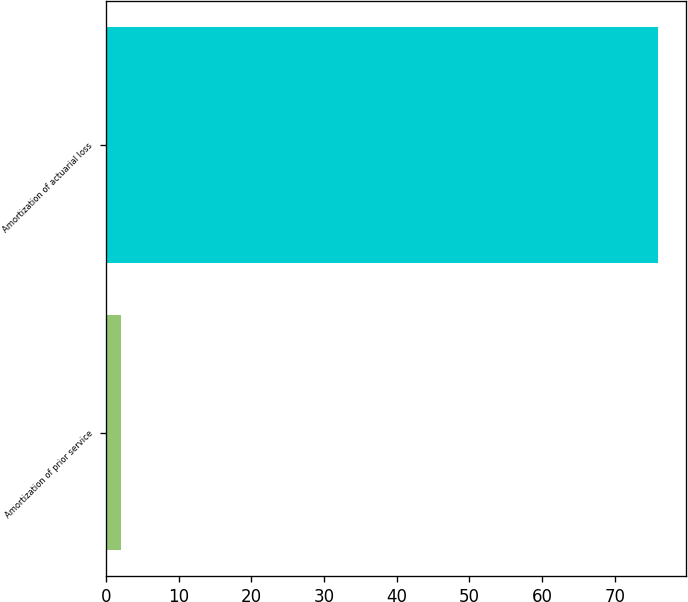Convert chart. <chart><loc_0><loc_0><loc_500><loc_500><bar_chart><fcel>Amortization of prior service<fcel>Amortization of actuarial loss<nl><fcel>2<fcel>76<nl></chart> 